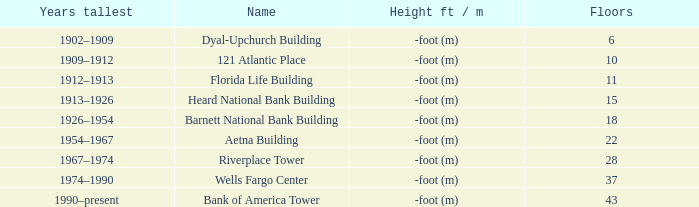How tall is the florida life building, completed before 1990? -foot (m). 